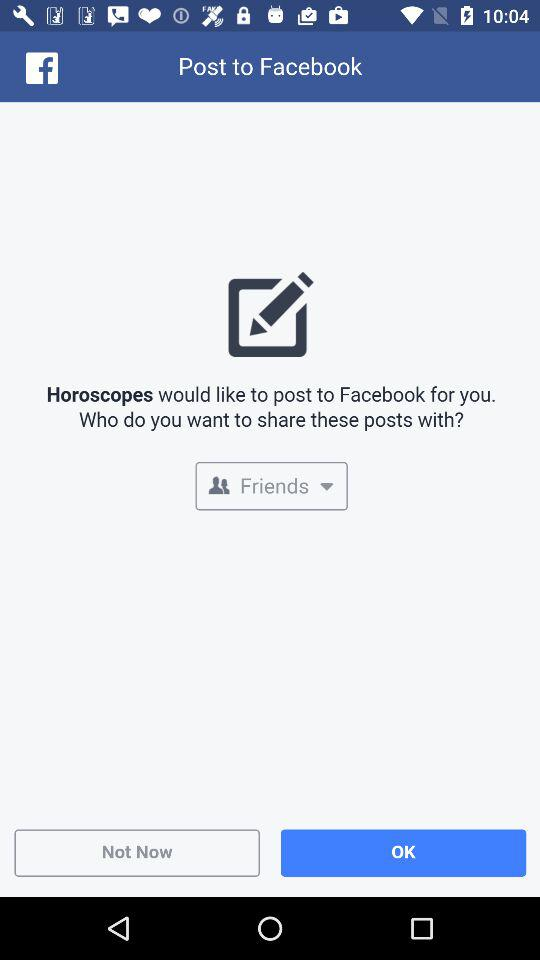With whom will these posts be shared? These posts will be shared with friends. 